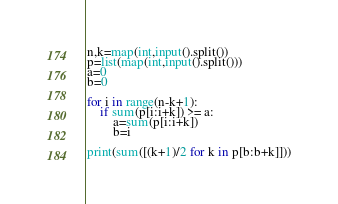<code> <loc_0><loc_0><loc_500><loc_500><_Python_>n,k=map(int,input().split())
p=list(map(int,input().split()))
a=0
b=0

for i in range(n-k+1):
    if sum(p[i:i+k]) >= a:
        a=sum(p[i:i+k]) 
        b=i

print(sum([(k+1)/2 for k in p[b:b+k]]))</code> 